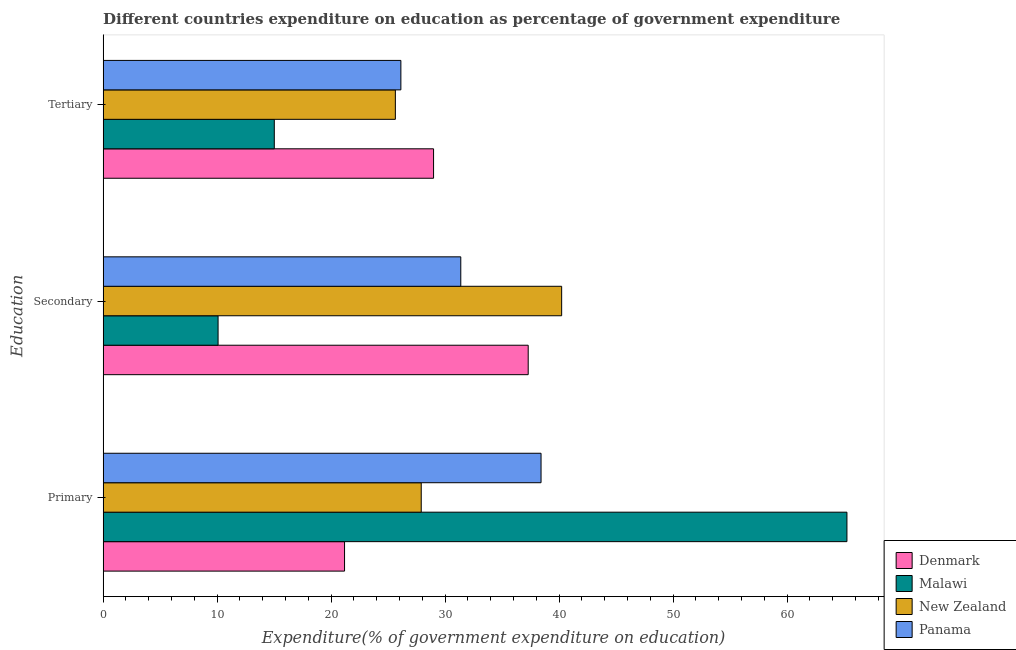How many groups of bars are there?
Keep it short and to the point. 3. Are the number of bars per tick equal to the number of legend labels?
Keep it short and to the point. Yes. Are the number of bars on each tick of the Y-axis equal?
Give a very brief answer. Yes. How many bars are there on the 3rd tick from the bottom?
Give a very brief answer. 4. What is the label of the 3rd group of bars from the top?
Make the answer very short. Primary. What is the expenditure on tertiary education in Malawi?
Your answer should be compact. 15.02. Across all countries, what is the maximum expenditure on primary education?
Provide a short and direct response. 65.26. Across all countries, what is the minimum expenditure on primary education?
Your answer should be compact. 21.18. In which country was the expenditure on tertiary education maximum?
Your response must be concise. Denmark. In which country was the expenditure on tertiary education minimum?
Make the answer very short. Malawi. What is the total expenditure on secondary education in the graph?
Give a very brief answer. 118.98. What is the difference between the expenditure on tertiary education in Malawi and that in Denmark?
Your response must be concise. -13.97. What is the difference between the expenditure on tertiary education in Malawi and the expenditure on secondary education in New Zealand?
Your answer should be compact. -25.21. What is the average expenditure on secondary education per country?
Provide a succinct answer. 29.75. What is the difference between the expenditure on secondary education and expenditure on tertiary education in Panama?
Your answer should be compact. 5.26. In how many countries, is the expenditure on tertiary education greater than 42 %?
Your answer should be compact. 0. What is the ratio of the expenditure on tertiary education in New Zealand to that in Panama?
Ensure brevity in your answer.  0.98. Is the expenditure on primary education in Malawi less than that in New Zealand?
Give a very brief answer. No. Is the difference between the expenditure on secondary education in Malawi and Denmark greater than the difference between the expenditure on tertiary education in Malawi and Denmark?
Offer a very short reply. No. What is the difference between the highest and the second highest expenditure on secondary education?
Your answer should be very brief. 2.93. What is the difference between the highest and the lowest expenditure on primary education?
Give a very brief answer. 44.08. In how many countries, is the expenditure on primary education greater than the average expenditure on primary education taken over all countries?
Offer a very short reply. 2. Is the sum of the expenditure on primary education in Panama and Denmark greater than the maximum expenditure on secondary education across all countries?
Keep it short and to the point. Yes. What does the 1st bar from the bottom in Secondary represents?
Keep it short and to the point. Denmark. Is it the case that in every country, the sum of the expenditure on primary education and expenditure on secondary education is greater than the expenditure on tertiary education?
Provide a succinct answer. Yes. Are all the bars in the graph horizontal?
Your response must be concise. Yes. How many countries are there in the graph?
Your answer should be very brief. 4. What is the difference between two consecutive major ticks on the X-axis?
Your response must be concise. 10. Are the values on the major ticks of X-axis written in scientific E-notation?
Make the answer very short. No. Where does the legend appear in the graph?
Ensure brevity in your answer.  Bottom right. What is the title of the graph?
Your response must be concise. Different countries expenditure on education as percentage of government expenditure. What is the label or title of the X-axis?
Provide a short and direct response. Expenditure(% of government expenditure on education). What is the label or title of the Y-axis?
Make the answer very short. Education. What is the Expenditure(% of government expenditure on education) of Denmark in Primary?
Your response must be concise. 21.18. What is the Expenditure(% of government expenditure on education) in Malawi in Primary?
Offer a terse response. 65.26. What is the Expenditure(% of government expenditure on education) of New Zealand in Primary?
Ensure brevity in your answer.  27.91. What is the Expenditure(% of government expenditure on education) in Panama in Primary?
Provide a short and direct response. 38.42. What is the Expenditure(% of government expenditure on education) of Denmark in Secondary?
Offer a very short reply. 37.29. What is the Expenditure(% of government expenditure on education) in Malawi in Secondary?
Provide a succinct answer. 10.08. What is the Expenditure(% of government expenditure on education) in New Zealand in Secondary?
Provide a short and direct response. 40.23. What is the Expenditure(% of government expenditure on education) of Panama in Secondary?
Your answer should be compact. 31.38. What is the Expenditure(% of government expenditure on education) of Denmark in Tertiary?
Offer a very short reply. 28.99. What is the Expenditure(% of government expenditure on education) of Malawi in Tertiary?
Your response must be concise. 15.02. What is the Expenditure(% of government expenditure on education) of New Zealand in Tertiary?
Make the answer very short. 25.64. What is the Expenditure(% of government expenditure on education) of Panama in Tertiary?
Offer a very short reply. 26.12. Across all Education, what is the maximum Expenditure(% of government expenditure on education) in Denmark?
Keep it short and to the point. 37.29. Across all Education, what is the maximum Expenditure(% of government expenditure on education) of Malawi?
Ensure brevity in your answer.  65.26. Across all Education, what is the maximum Expenditure(% of government expenditure on education) of New Zealand?
Your answer should be compact. 40.23. Across all Education, what is the maximum Expenditure(% of government expenditure on education) of Panama?
Offer a terse response. 38.42. Across all Education, what is the minimum Expenditure(% of government expenditure on education) in Denmark?
Keep it short and to the point. 21.18. Across all Education, what is the minimum Expenditure(% of government expenditure on education) in Malawi?
Give a very brief answer. 10.08. Across all Education, what is the minimum Expenditure(% of government expenditure on education) of New Zealand?
Your answer should be very brief. 25.64. Across all Education, what is the minimum Expenditure(% of government expenditure on education) in Panama?
Make the answer very short. 26.12. What is the total Expenditure(% of government expenditure on education) of Denmark in the graph?
Provide a succinct answer. 87.46. What is the total Expenditure(% of government expenditure on education) of Malawi in the graph?
Make the answer very short. 90.36. What is the total Expenditure(% of government expenditure on education) of New Zealand in the graph?
Your response must be concise. 93.77. What is the total Expenditure(% of government expenditure on education) of Panama in the graph?
Offer a very short reply. 95.92. What is the difference between the Expenditure(% of government expenditure on education) in Denmark in Primary and that in Secondary?
Give a very brief answer. -16.11. What is the difference between the Expenditure(% of government expenditure on education) in Malawi in Primary and that in Secondary?
Your answer should be compact. 55.17. What is the difference between the Expenditure(% of government expenditure on education) of New Zealand in Primary and that in Secondary?
Give a very brief answer. -12.32. What is the difference between the Expenditure(% of government expenditure on education) of Panama in Primary and that in Secondary?
Ensure brevity in your answer.  7.04. What is the difference between the Expenditure(% of government expenditure on education) of Denmark in Primary and that in Tertiary?
Offer a very short reply. -7.81. What is the difference between the Expenditure(% of government expenditure on education) of Malawi in Primary and that in Tertiary?
Your answer should be very brief. 50.24. What is the difference between the Expenditure(% of government expenditure on education) of New Zealand in Primary and that in Tertiary?
Your response must be concise. 2.27. What is the difference between the Expenditure(% of government expenditure on education) in Panama in Primary and that in Tertiary?
Make the answer very short. 12.3. What is the difference between the Expenditure(% of government expenditure on education) of Denmark in Secondary and that in Tertiary?
Your response must be concise. 8.3. What is the difference between the Expenditure(% of government expenditure on education) in Malawi in Secondary and that in Tertiary?
Ensure brevity in your answer.  -4.93. What is the difference between the Expenditure(% of government expenditure on education) in New Zealand in Secondary and that in Tertiary?
Provide a succinct answer. 14.59. What is the difference between the Expenditure(% of government expenditure on education) in Panama in Secondary and that in Tertiary?
Offer a very short reply. 5.25. What is the difference between the Expenditure(% of government expenditure on education) of Denmark in Primary and the Expenditure(% of government expenditure on education) of Malawi in Secondary?
Your answer should be very brief. 11.1. What is the difference between the Expenditure(% of government expenditure on education) of Denmark in Primary and the Expenditure(% of government expenditure on education) of New Zealand in Secondary?
Your answer should be compact. -19.05. What is the difference between the Expenditure(% of government expenditure on education) in Denmark in Primary and the Expenditure(% of government expenditure on education) in Panama in Secondary?
Your answer should be compact. -10.2. What is the difference between the Expenditure(% of government expenditure on education) of Malawi in Primary and the Expenditure(% of government expenditure on education) of New Zealand in Secondary?
Your response must be concise. 25.03. What is the difference between the Expenditure(% of government expenditure on education) in Malawi in Primary and the Expenditure(% of government expenditure on education) in Panama in Secondary?
Make the answer very short. 33.88. What is the difference between the Expenditure(% of government expenditure on education) of New Zealand in Primary and the Expenditure(% of government expenditure on education) of Panama in Secondary?
Make the answer very short. -3.47. What is the difference between the Expenditure(% of government expenditure on education) of Denmark in Primary and the Expenditure(% of government expenditure on education) of Malawi in Tertiary?
Keep it short and to the point. 6.16. What is the difference between the Expenditure(% of government expenditure on education) in Denmark in Primary and the Expenditure(% of government expenditure on education) in New Zealand in Tertiary?
Your response must be concise. -4.46. What is the difference between the Expenditure(% of government expenditure on education) of Denmark in Primary and the Expenditure(% of government expenditure on education) of Panama in Tertiary?
Offer a terse response. -4.94. What is the difference between the Expenditure(% of government expenditure on education) in Malawi in Primary and the Expenditure(% of government expenditure on education) in New Zealand in Tertiary?
Provide a short and direct response. 39.62. What is the difference between the Expenditure(% of government expenditure on education) of Malawi in Primary and the Expenditure(% of government expenditure on education) of Panama in Tertiary?
Give a very brief answer. 39.13. What is the difference between the Expenditure(% of government expenditure on education) in New Zealand in Primary and the Expenditure(% of government expenditure on education) in Panama in Tertiary?
Provide a short and direct response. 1.79. What is the difference between the Expenditure(% of government expenditure on education) in Denmark in Secondary and the Expenditure(% of government expenditure on education) in Malawi in Tertiary?
Give a very brief answer. 22.28. What is the difference between the Expenditure(% of government expenditure on education) in Denmark in Secondary and the Expenditure(% of government expenditure on education) in New Zealand in Tertiary?
Offer a very short reply. 11.66. What is the difference between the Expenditure(% of government expenditure on education) of Denmark in Secondary and the Expenditure(% of government expenditure on education) of Panama in Tertiary?
Keep it short and to the point. 11.17. What is the difference between the Expenditure(% of government expenditure on education) of Malawi in Secondary and the Expenditure(% of government expenditure on education) of New Zealand in Tertiary?
Make the answer very short. -15.55. What is the difference between the Expenditure(% of government expenditure on education) in Malawi in Secondary and the Expenditure(% of government expenditure on education) in Panama in Tertiary?
Provide a succinct answer. -16.04. What is the difference between the Expenditure(% of government expenditure on education) in New Zealand in Secondary and the Expenditure(% of government expenditure on education) in Panama in Tertiary?
Give a very brief answer. 14.11. What is the average Expenditure(% of government expenditure on education) in Denmark per Education?
Provide a succinct answer. 29.15. What is the average Expenditure(% of government expenditure on education) in Malawi per Education?
Offer a terse response. 30.12. What is the average Expenditure(% of government expenditure on education) of New Zealand per Education?
Keep it short and to the point. 31.26. What is the average Expenditure(% of government expenditure on education) of Panama per Education?
Give a very brief answer. 31.97. What is the difference between the Expenditure(% of government expenditure on education) in Denmark and Expenditure(% of government expenditure on education) in Malawi in Primary?
Keep it short and to the point. -44.08. What is the difference between the Expenditure(% of government expenditure on education) in Denmark and Expenditure(% of government expenditure on education) in New Zealand in Primary?
Provide a succinct answer. -6.73. What is the difference between the Expenditure(% of government expenditure on education) of Denmark and Expenditure(% of government expenditure on education) of Panama in Primary?
Your answer should be very brief. -17.24. What is the difference between the Expenditure(% of government expenditure on education) of Malawi and Expenditure(% of government expenditure on education) of New Zealand in Primary?
Your answer should be very brief. 37.35. What is the difference between the Expenditure(% of government expenditure on education) in Malawi and Expenditure(% of government expenditure on education) in Panama in Primary?
Make the answer very short. 26.84. What is the difference between the Expenditure(% of government expenditure on education) of New Zealand and Expenditure(% of government expenditure on education) of Panama in Primary?
Your response must be concise. -10.51. What is the difference between the Expenditure(% of government expenditure on education) in Denmark and Expenditure(% of government expenditure on education) in Malawi in Secondary?
Offer a terse response. 27.21. What is the difference between the Expenditure(% of government expenditure on education) in Denmark and Expenditure(% of government expenditure on education) in New Zealand in Secondary?
Make the answer very short. -2.93. What is the difference between the Expenditure(% of government expenditure on education) of Denmark and Expenditure(% of government expenditure on education) of Panama in Secondary?
Offer a very short reply. 5.92. What is the difference between the Expenditure(% of government expenditure on education) of Malawi and Expenditure(% of government expenditure on education) of New Zealand in Secondary?
Your answer should be compact. -30.14. What is the difference between the Expenditure(% of government expenditure on education) in Malawi and Expenditure(% of government expenditure on education) in Panama in Secondary?
Your answer should be very brief. -21.29. What is the difference between the Expenditure(% of government expenditure on education) of New Zealand and Expenditure(% of government expenditure on education) of Panama in Secondary?
Give a very brief answer. 8.85. What is the difference between the Expenditure(% of government expenditure on education) in Denmark and Expenditure(% of government expenditure on education) in Malawi in Tertiary?
Offer a very short reply. 13.97. What is the difference between the Expenditure(% of government expenditure on education) in Denmark and Expenditure(% of government expenditure on education) in New Zealand in Tertiary?
Offer a terse response. 3.35. What is the difference between the Expenditure(% of government expenditure on education) of Denmark and Expenditure(% of government expenditure on education) of Panama in Tertiary?
Your response must be concise. 2.87. What is the difference between the Expenditure(% of government expenditure on education) of Malawi and Expenditure(% of government expenditure on education) of New Zealand in Tertiary?
Provide a succinct answer. -10.62. What is the difference between the Expenditure(% of government expenditure on education) of Malawi and Expenditure(% of government expenditure on education) of Panama in Tertiary?
Provide a short and direct response. -11.1. What is the difference between the Expenditure(% of government expenditure on education) of New Zealand and Expenditure(% of government expenditure on education) of Panama in Tertiary?
Your answer should be compact. -0.48. What is the ratio of the Expenditure(% of government expenditure on education) in Denmark in Primary to that in Secondary?
Ensure brevity in your answer.  0.57. What is the ratio of the Expenditure(% of government expenditure on education) in Malawi in Primary to that in Secondary?
Offer a terse response. 6.47. What is the ratio of the Expenditure(% of government expenditure on education) in New Zealand in Primary to that in Secondary?
Ensure brevity in your answer.  0.69. What is the ratio of the Expenditure(% of government expenditure on education) in Panama in Primary to that in Secondary?
Keep it short and to the point. 1.22. What is the ratio of the Expenditure(% of government expenditure on education) of Denmark in Primary to that in Tertiary?
Offer a terse response. 0.73. What is the ratio of the Expenditure(% of government expenditure on education) in Malawi in Primary to that in Tertiary?
Your answer should be compact. 4.35. What is the ratio of the Expenditure(% of government expenditure on education) in New Zealand in Primary to that in Tertiary?
Your answer should be very brief. 1.09. What is the ratio of the Expenditure(% of government expenditure on education) in Panama in Primary to that in Tertiary?
Your response must be concise. 1.47. What is the ratio of the Expenditure(% of government expenditure on education) of Denmark in Secondary to that in Tertiary?
Provide a succinct answer. 1.29. What is the ratio of the Expenditure(% of government expenditure on education) of Malawi in Secondary to that in Tertiary?
Your response must be concise. 0.67. What is the ratio of the Expenditure(% of government expenditure on education) of New Zealand in Secondary to that in Tertiary?
Your response must be concise. 1.57. What is the ratio of the Expenditure(% of government expenditure on education) of Panama in Secondary to that in Tertiary?
Ensure brevity in your answer.  1.2. What is the difference between the highest and the second highest Expenditure(% of government expenditure on education) in Denmark?
Provide a succinct answer. 8.3. What is the difference between the highest and the second highest Expenditure(% of government expenditure on education) in Malawi?
Your answer should be very brief. 50.24. What is the difference between the highest and the second highest Expenditure(% of government expenditure on education) of New Zealand?
Your response must be concise. 12.32. What is the difference between the highest and the second highest Expenditure(% of government expenditure on education) of Panama?
Offer a terse response. 7.04. What is the difference between the highest and the lowest Expenditure(% of government expenditure on education) of Denmark?
Provide a succinct answer. 16.11. What is the difference between the highest and the lowest Expenditure(% of government expenditure on education) of Malawi?
Provide a short and direct response. 55.17. What is the difference between the highest and the lowest Expenditure(% of government expenditure on education) of New Zealand?
Give a very brief answer. 14.59. What is the difference between the highest and the lowest Expenditure(% of government expenditure on education) in Panama?
Your answer should be very brief. 12.3. 